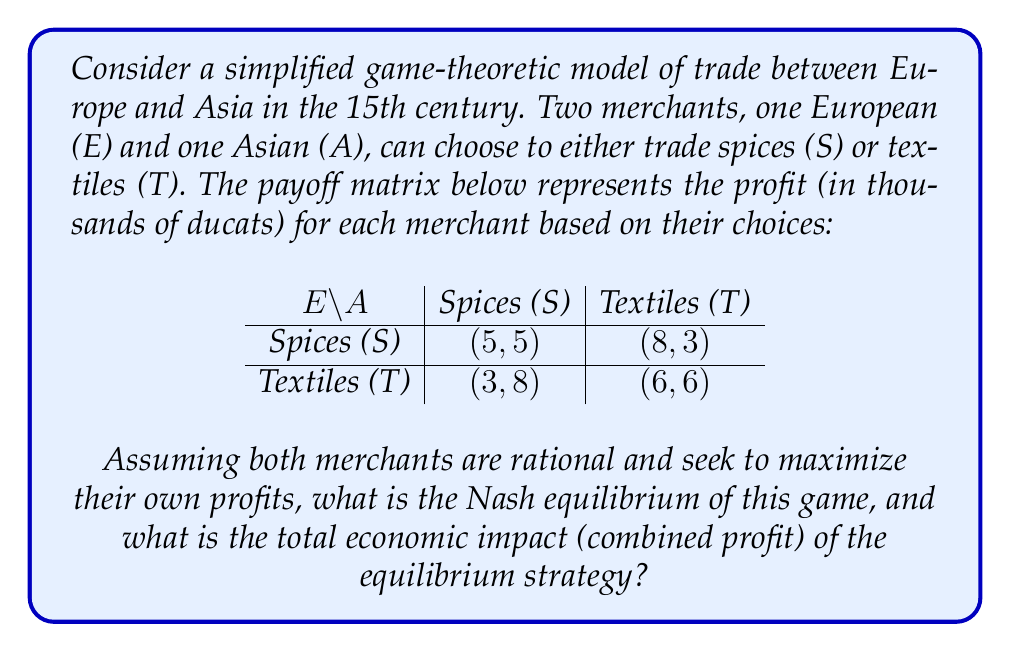Can you solve this math problem? To solve this game-theoretic problem, we need to follow these steps:

1. Identify the dominant strategies for each player (if any).
2. Find the Nash equilibrium.
3. Calculate the total economic impact.

Step 1: Identifying dominant strategies

For the European merchant (E):
- If A chooses S: E prefers S (5 > 3)
- If A chooses T: E prefers S (8 > 6)
S is a dominant strategy for E.

For the Asian merchant (A):
- If E chooses S: A prefers S (5 > 3)
- If E chooses T: A prefers T (6 > 3)
There is no dominant strategy for A.

Step 2: Finding the Nash equilibrium

Since S is a dominant strategy for E, we know E will choose S. Given this:
- If E chooses S: A prefers S (5 > 3)

Therefore, the Nash equilibrium is (S, S), where both merchants choose to trade spices.

Step 3: Calculating the total economic impact

At the Nash equilibrium (S, S), the payoffs are (5, 5). The total economic impact is the sum of these payoffs:

$5 + 5 = 10$ thousand ducats

This represents the combined profit of both merchants when they both choose to trade spices, which is the stable outcome of this game-theoretic model.
Answer: The Nash equilibrium is (S, S), where both merchants choose to trade spices. The total economic impact (combined profit) of this equilibrium strategy is 10 thousand ducats. 